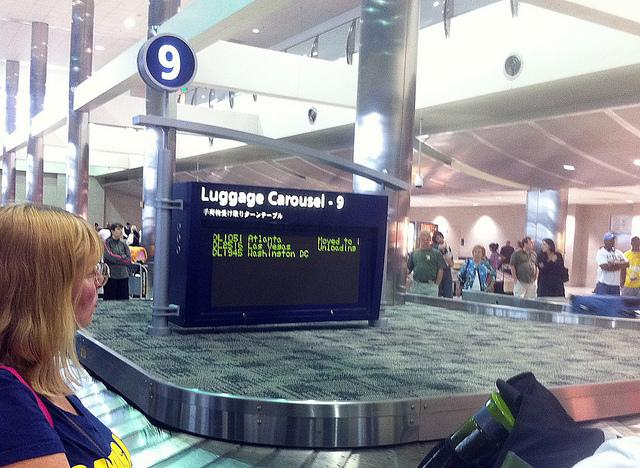What country's cities are listed on the information board? united states 